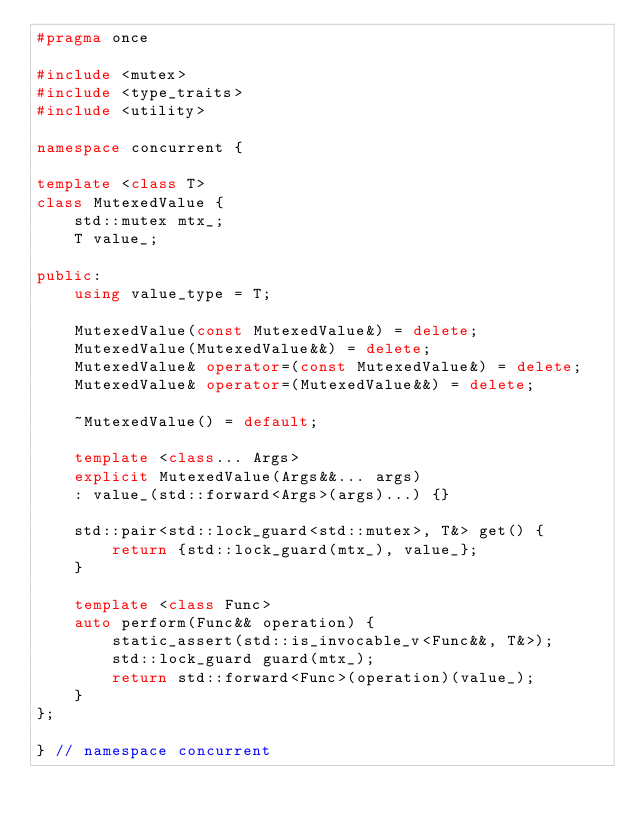<code> <loc_0><loc_0><loc_500><loc_500><_C++_>#pragma once

#include <mutex>
#include <type_traits>
#include <utility>

namespace concurrent {

template <class T>
class MutexedValue {
    std::mutex mtx_;
    T value_;

public:
    using value_type = T;

    MutexedValue(const MutexedValue&) = delete;
    MutexedValue(MutexedValue&&) = delete;
    MutexedValue& operator=(const MutexedValue&) = delete;
    MutexedValue& operator=(MutexedValue&&) = delete;

    ~MutexedValue() = default;

    template <class... Args>
    explicit MutexedValue(Args&&... args)
    : value_(std::forward<Args>(args)...) {}

    std::pair<std::lock_guard<std::mutex>, T&> get() {
        return {std::lock_guard(mtx_), value_};
    }

    template <class Func>
    auto perform(Func&& operation) {
        static_assert(std::is_invocable_v<Func&&, T&>);
        std::lock_guard guard(mtx_);
        return std::forward<Func>(operation)(value_);
    }
};

} // namespace concurrent
</code> 